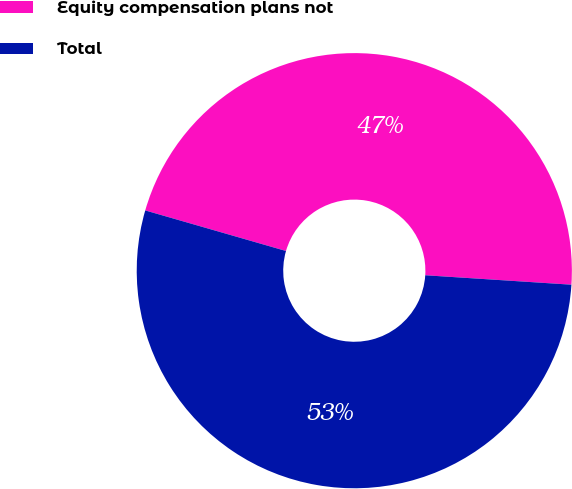Convert chart to OTSL. <chart><loc_0><loc_0><loc_500><loc_500><pie_chart><fcel>Equity compensation plans not<fcel>Total<nl><fcel>46.56%<fcel>53.44%<nl></chart> 